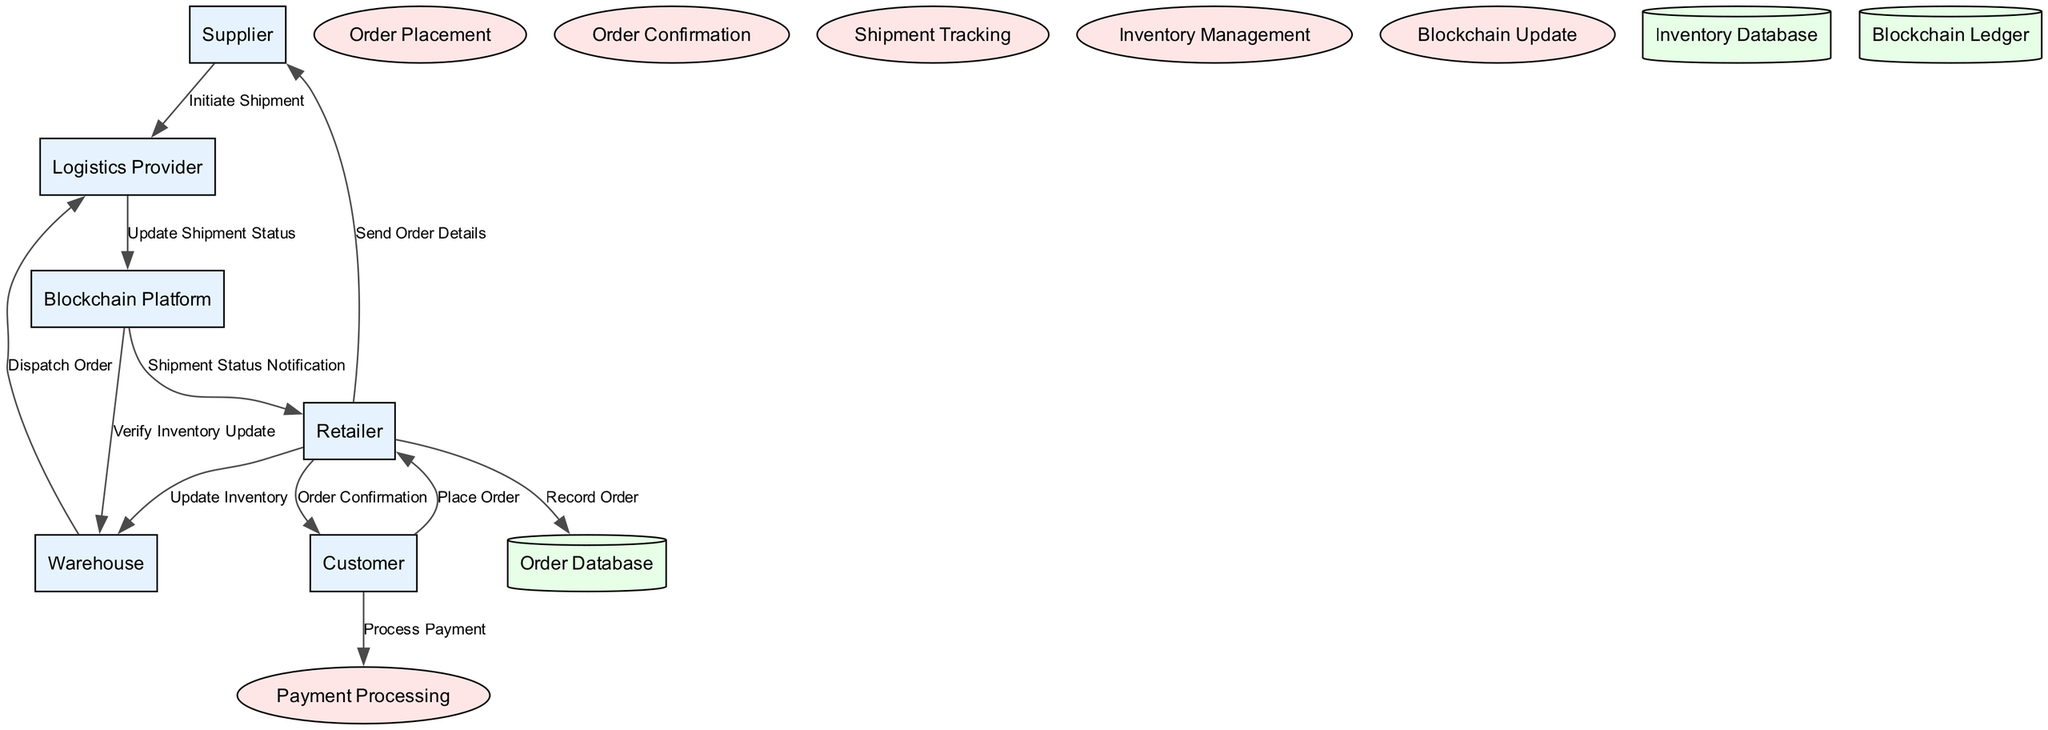What is the total number of entities in the diagram? The diagram lists six entities: Supplier, Warehouse, Blockchain Platform, Retailer, Customer, and Logistics Provider. Counting these gives a total of six.
Answer: 6 What is the process that handles customer payments? The diagram specifies the "Payment Processing" as the process responsible for handling customer payments.
Answer: Payment Processing Which entity is responsible for dispatching orders to the customer? According to the diagram, the "Logistics Provider" is tasked with dispatching orders to the customer, as shown in the flow between Warehouse and Logistics Provider.
Answer: Logistics Provider How many data flows originate from the Retailer? The diagram shows four data flows originating from the Retailer: "Record Order," "Send Order Details," "Update Inventory," and "Order Confirmation." Counting these flows results in four.
Answer: 4 What is the flow name associated with initiating a shipment? The flow from Supplier to Logistics Provider is named "Initiate Shipment," indicating the action of starting the shipping process.
Answer: Initiate Shipment Name the data store that records all supply chain transactions. The diagram denotes "Blockchain Ledger" as the data store that records all transactions within the supply chain.
Answer: Blockchain Ledger Which process is responsible for updating the shipment status on the blockchain? The diagram indicates that the "Blockchain Update" process is responsible for recording each transaction and movement of goods on the blockchain.
Answer: Blockchain Update What is the first action taken after a customer places an order? After a customer places an order, the first action taken is to "Record Order" in the Order Database by the retailer, as per the flow illustrated in the diagram.
Answer: Record Order How do logistics providers communicate shipment status to the blockchain? According to the diagram, Logistics Providers communicate shipment status to the Blockchain Platform through a flow titled "Update Shipment Status." This flow illustrates the process of notifying the blockchain about the shipment's status.
Answer: Update Shipment Status 